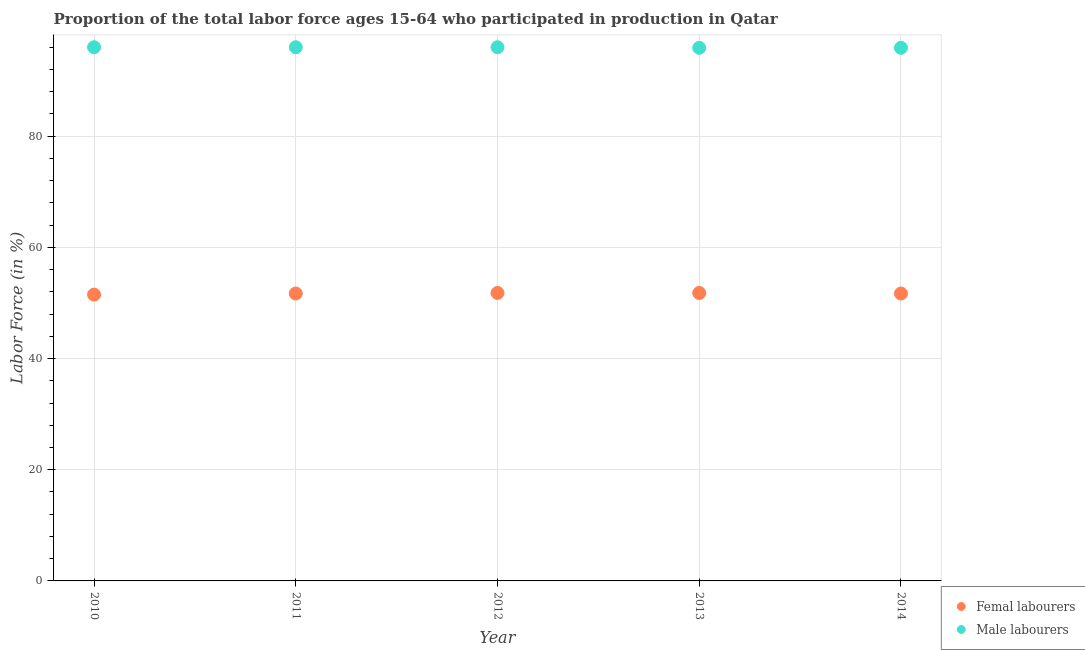Is the number of dotlines equal to the number of legend labels?
Offer a terse response. Yes. What is the percentage of female labor force in 2014?
Give a very brief answer. 51.7. Across all years, what is the maximum percentage of male labour force?
Provide a short and direct response. 96. Across all years, what is the minimum percentage of male labour force?
Ensure brevity in your answer.  95.9. What is the total percentage of male labour force in the graph?
Ensure brevity in your answer.  479.8. What is the difference between the percentage of male labour force in 2011 and that in 2013?
Give a very brief answer. 0.1. What is the difference between the percentage of female labor force in 2011 and the percentage of male labour force in 2014?
Keep it short and to the point. -44.2. What is the average percentage of female labor force per year?
Keep it short and to the point. 51.7. In the year 2014, what is the difference between the percentage of female labor force and percentage of male labour force?
Provide a succinct answer. -44.2. In how many years, is the percentage of female labor force greater than 60 %?
Offer a very short reply. 0. What is the ratio of the percentage of male labour force in 2011 to that in 2012?
Keep it short and to the point. 1. Is the difference between the percentage of female labor force in 2011 and 2013 greater than the difference between the percentage of male labour force in 2011 and 2013?
Make the answer very short. No. What is the difference between the highest and the lowest percentage of male labour force?
Provide a succinct answer. 0.1. Is the sum of the percentage of male labour force in 2013 and 2014 greater than the maximum percentage of female labor force across all years?
Ensure brevity in your answer.  Yes. Is the percentage of male labour force strictly greater than the percentage of female labor force over the years?
Offer a terse response. Yes. Is the percentage of male labour force strictly less than the percentage of female labor force over the years?
Offer a very short reply. No. How many years are there in the graph?
Give a very brief answer. 5. What is the difference between two consecutive major ticks on the Y-axis?
Provide a succinct answer. 20. Are the values on the major ticks of Y-axis written in scientific E-notation?
Give a very brief answer. No. Does the graph contain grids?
Your answer should be compact. Yes. How many legend labels are there?
Ensure brevity in your answer.  2. How are the legend labels stacked?
Your response must be concise. Vertical. What is the title of the graph?
Your response must be concise. Proportion of the total labor force ages 15-64 who participated in production in Qatar. What is the label or title of the Y-axis?
Keep it short and to the point. Labor Force (in %). What is the Labor Force (in %) of Femal labourers in 2010?
Offer a very short reply. 51.5. What is the Labor Force (in %) of Male labourers in 2010?
Your response must be concise. 96. What is the Labor Force (in %) in Femal labourers in 2011?
Make the answer very short. 51.7. What is the Labor Force (in %) of Male labourers in 2011?
Your answer should be compact. 96. What is the Labor Force (in %) of Femal labourers in 2012?
Ensure brevity in your answer.  51.8. What is the Labor Force (in %) in Male labourers in 2012?
Your answer should be compact. 96. What is the Labor Force (in %) in Femal labourers in 2013?
Give a very brief answer. 51.8. What is the Labor Force (in %) of Male labourers in 2013?
Make the answer very short. 95.9. What is the Labor Force (in %) of Femal labourers in 2014?
Your answer should be very brief. 51.7. What is the Labor Force (in %) of Male labourers in 2014?
Give a very brief answer. 95.9. Across all years, what is the maximum Labor Force (in %) of Femal labourers?
Your answer should be compact. 51.8. Across all years, what is the maximum Labor Force (in %) in Male labourers?
Your answer should be very brief. 96. Across all years, what is the minimum Labor Force (in %) in Femal labourers?
Keep it short and to the point. 51.5. Across all years, what is the minimum Labor Force (in %) in Male labourers?
Your answer should be compact. 95.9. What is the total Labor Force (in %) of Femal labourers in the graph?
Give a very brief answer. 258.5. What is the total Labor Force (in %) in Male labourers in the graph?
Keep it short and to the point. 479.8. What is the difference between the Labor Force (in %) in Femal labourers in 2010 and that in 2011?
Keep it short and to the point. -0.2. What is the difference between the Labor Force (in %) in Male labourers in 2010 and that in 2011?
Your answer should be very brief. 0. What is the difference between the Labor Force (in %) in Male labourers in 2010 and that in 2012?
Offer a very short reply. 0. What is the difference between the Labor Force (in %) of Femal labourers in 2011 and that in 2012?
Provide a succinct answer. -0.1. What is the difference between the Labor Force (in %) of Male labourers in 2011 and that in 2012?
Provide a succinct answer. 0. What is the difference between the Labor Force (in %) in Femal labourers in 2011 and that in 2013?
Give a very brief answer. -0.1. What is the difference between the Labor Force (in %) of Male labourers in 2011 and that in 2013?
Give a very brief answer. 0.1. What is the difference between the Labor Force (in %) of Male labourers in 2011 and that in 2014?
Give a very brief answer. 0.1. What is the difference between the Labor Force (in %) of Femal labourers in 2012 and that in 2013?
Ensure brevity in your answer.  0. What is the difference between the Labor Force (in %) of Femal labourers in 2012 and that in 2014?
Give a very brief answer. 0.1. What is the difference between the Labor Force (in %) of Male labourers in 2013 and that in 2014?
Ensure brevity in your answer.  0. What is the difference between the Labor Force (in %) in Femal labourers in 2010 and the Labor Force (in %) in Male labourers in 2011?
Offer a terse response. -44.5. What is the difference between the Labor Force (in %) of Femal labourers in 2010 and the Labor Force (in %) of Male labourers in 2012?
Give a very brief answer. -44.5. What is the difference between the Labor Force (in %) of Femal labourers in 2010 and the Labor Force (in %) of Male labourers in 2013?
Keep it short and to the point. -44.4. What is the difference between the Labor Force (in %) in Femal labourers in 2010 and the Labor Force (in %) in Male labourers in 2014?
Provide a short and direct response. -44.4. What is the difference between the Labor Force (in %) in Femal labourers in 2011 and the Labor Force (in %) in Male labourers in 2012?
Make the answer very short. -44.3. What is the difference between the Labor Force (in %) in Femal labourers in 2011 and the Labor Force (in %) in Male labourers in 2013?
Your answer should be very brief. -44.2. What is the difference between the Labor Force (in %) of Femal labourers in 2011 and the Labor Force (in %) of Male labourers in 2014?
Make the answer very short. -44.2. What is the difference between the Labor Force (in %) in Femal labourers in 2012 and the Labor Force (in %) in Male labourers in 2013?
Your response must be concise. -44.1. What is the difference between the Labor Force (in %) of Femal labourers in 2012 and the Labor Force (in %) of Male labourers in 2014?
Give a very brief answer. -44.1. What is the difference between the Labor Force (in %) of Femal labourers in 2013 and the Labor Force (in %) of Male labourers in 2014?
Ensure brevity in your answer.  -44.1. What is the average Labor Force (in %) in Femal labourers per year?
Ensure brevity in your answer.  51.7. What is the average Labor Force (in %) in Male labourers per year?
Give a very brief answer. 95.96. In the year 2010, what is the difference between the Labor Force (in %) in Femal labourers and Labor Force (in %) in Male labourers?
Offer a terse response. -44.5. In the year 2011, what is the difference between the Labor Force (in %) of Femal labourers and Labor Force (in %) of Male labourers?
Your response must be concise. -44.3. In the year 2012, what is the difference between the Labor Force (in %) of Femal labourers and Labor Force (in %) of Male labourers?
Provide a short and direct response. -44.2. In the year 2013, what is the difference between the Labor Force (in %) of Femal labourers and Labor Force (in %) of Male labourers?
Provide a short and direct response. -44.1. In the year 2014, what is the difference between the Labor Force (in %) of Femal labourers and Labor Force (in %) of Male labourers?
Ensure brevity in your answer.  -44.2. What is the ratio of the Labor Force (in %) of Male labourers in 2010 to that in 2011?
Your answer should be very brief. 1. What is the ratio of the Labor Force (in %) of Femal labourers in 2010 to that in 2012?
Your answer should be very brief. 0.99. What is the ratio of the Labor Force (in %) of Male labourers in 2010 to that in 2013?
Your response must be concise. 1. What is the ratio of the Labor Force (in %) in Femal labourers in 2011 to that in 2013?
Keep it short and to the point. 1. What is the ratio of the Labor Force (in %) of Male labourers in 2011 to that in 2014?
Provide a short and direct response. 1. What is the ratio of the Labor Force (in %) of Femal labourers in 2012 to that in 2013?
Your answer should be compact. 1. What is the ratio of the Labor Force (in %) of Male labourers in 2012 to that in 2014?
Give a very brief answer. 1. What is the difference between the highest and the second highest Labor Force (in %) in Femal labourers?
Your response must be concise. 0. What is the difference between the highest and the second highest Labor Force (in %) of Male labourers?
Provide a short and direct response. 0. What is the difference between the highest and the lowest Labor Force (in %) of Femal labourers?
Provide a short and direct response. 0.3. What is the difference between the highest and the lowest Labor Force (in %) of Male labourers?
Provide a short and direct response. 0.1. 